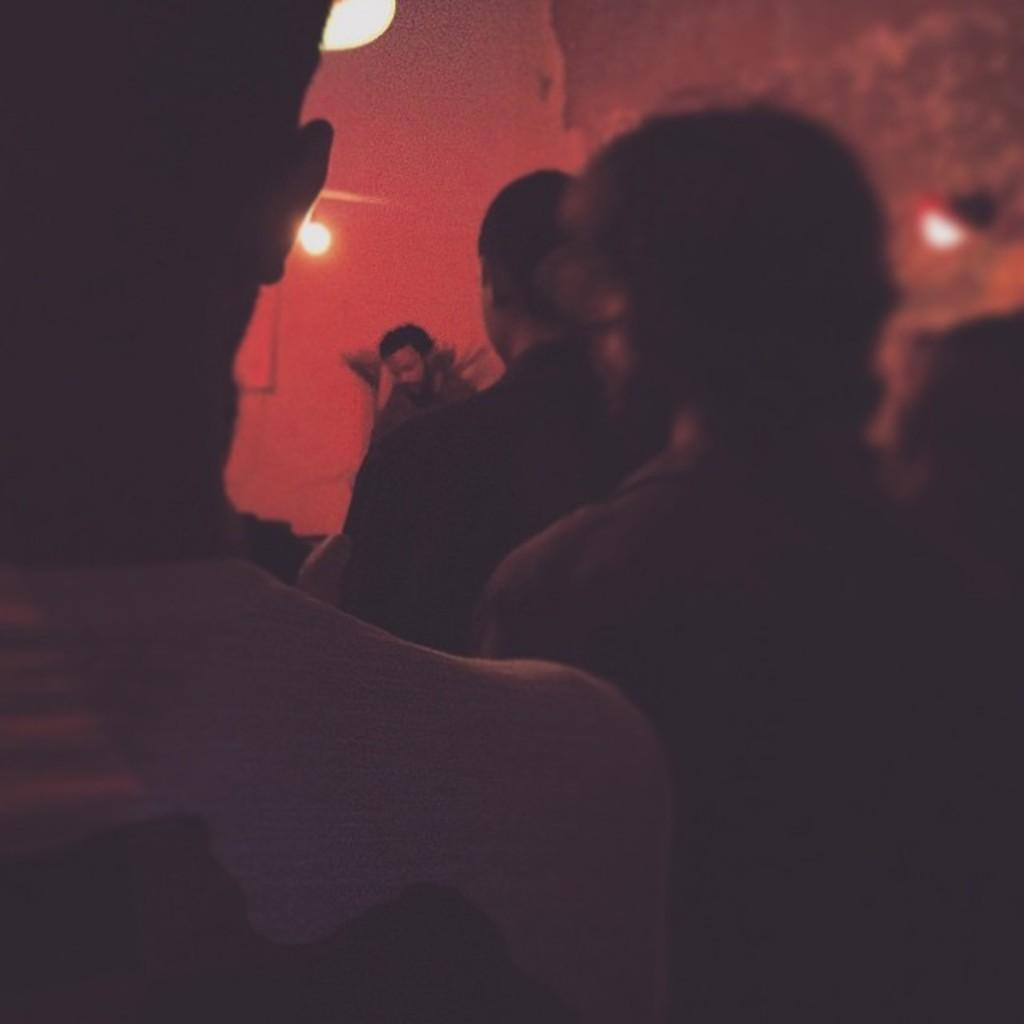What is happening in the image? There is a group of people standing in the image. Can you describe the setting of the image? There is a person standing in the background of the image. What can be seen in the image besides the people? There are lights visible in the image. What type of amusement can be seen in the image? There is no amusement present in the image; it features a group of people standing and a person in the background. What unit of time is being measured by the watch in the image? There is no watch present in the image. 